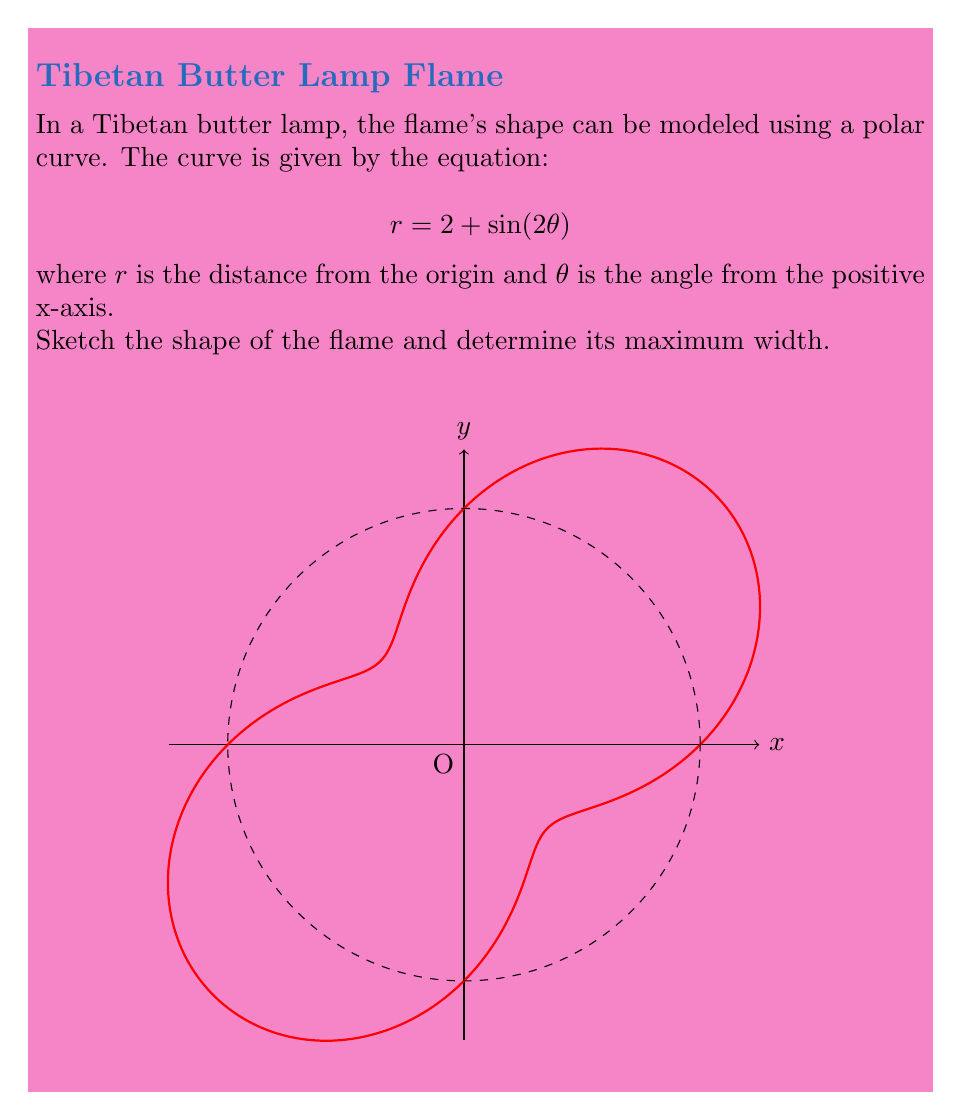Teach me how to tackle this problem. To solve this problem, let's follow these steps:

1) The given equation $r = 2 + \sin(2\theta)$ is in polar form. The base radius is 2, and $\sin(2\theta)$ causes the curve to oscillate around this base circle.

2) To find the maximum width, we need to find the maximum value of $r$:

   $r_{max} = 2 + \max(\sin(2\theta))$

3) We know that the maximum value of sine is 1, so:

   $r_{max} = 2 + 1 = 3$

4) The maximum width of the flame is twice this value (diameter):

   $\text{Maximum width} = 2 \cdot r_{max} = 2 \cdot 3 = 6$

5) The shape of the flame, as shown in the sketch, resembles a four-lobed rose curve. This is because $\sin(2\theta)$ completes two full cycles as $\theta$ goes from 0 to $2\pi$, creating four "petals" or lobes.

6) The dashed circle in the sketch represents the base circle with radius 2, and the solid red curve shows how the flame's shape oscillates around this circle.
Answer: 6 units 